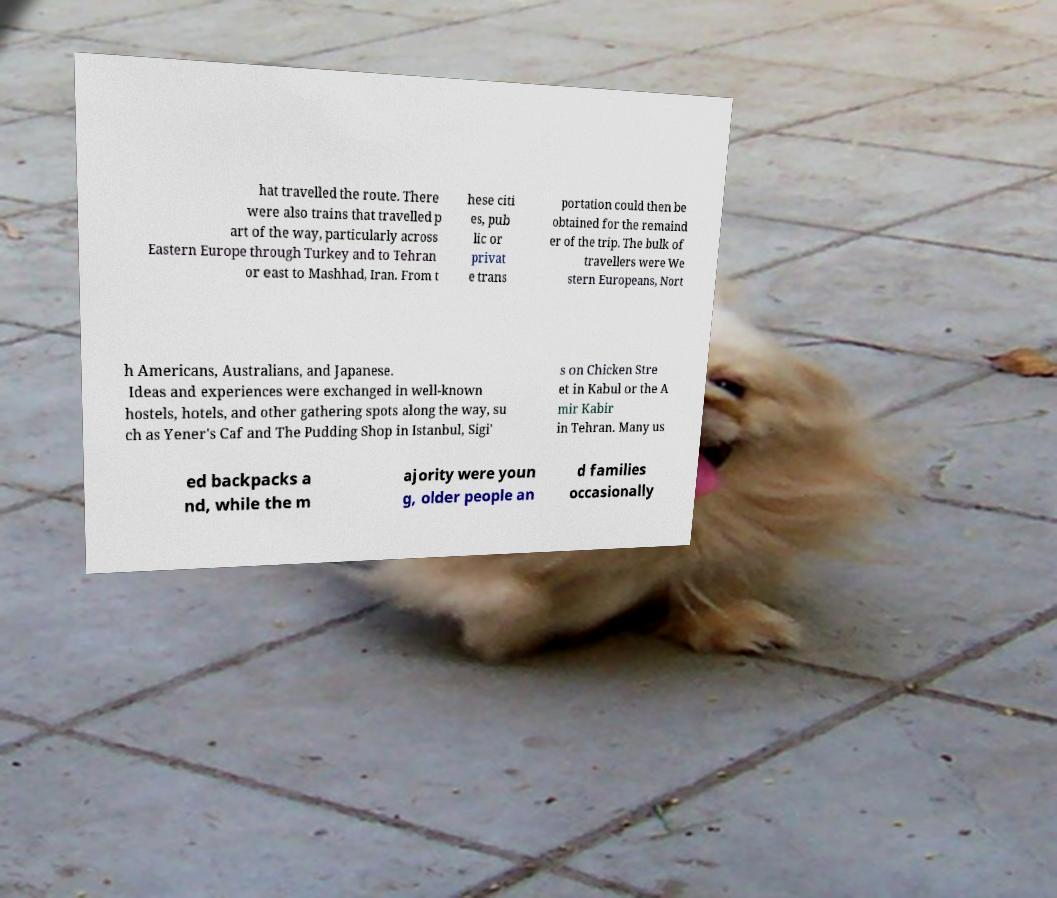Can you accurately transcribe the text from the provided image for me? hat travelled the route. There were also trains that travelled p art of the way, particularly across Eastern Europe through Turkey and to Tehran or east to Mashhad, Iran. From t hese citi es, pub lic or privat e trans portation could then be obtained for the remaind er of the trip. The bulk of travellers were We stern Europeans, Nort h Americans, Australians, and Japanese. Ideas and experiences were exchanged in well-known hostels, hotels, and other gathering spots along the way, su ch as Yener's Caf and The Pudding Shop in Istanbul, Sigi' s on Chicken Stre et in Kabul or the A mir Kabir in Tehran. Many us ed backpacks a nd, while the m ajority were youn g, older people an d families occasionally 